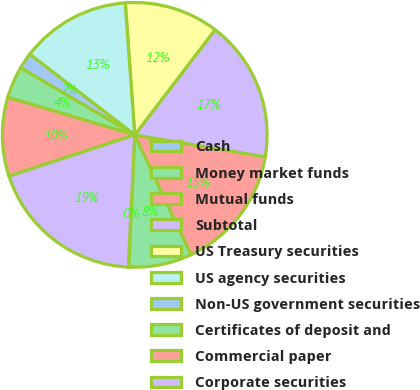Convert chart to OTSL. <chart><loc_0><loc_0><loc_500><loc_500><pie_chart><fcel>Cash<fcel>Money market funds<fcel>Mutual funds<fcel>Subtotal<fcel>US Treasury securities<fcel>US agency securities<fcel>Non-US government securities<fcel>Certificates of deposit and<fcel>Commercial paper<fcel>Corporate securities<nl><fcel>0.06%<fcel>7.71%<fcel>15.35%<fcel>17.27%<fcel>11.53%<fcel>13.44%<fcel>1.97%<fcel>3.88%<fcel>9.62%<fcel>19.18%<nl></chart> 